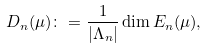Convert formula to latex. <formula><loc_0><loc_0><loc_500><loc_500>D _ { n } ( \mu ) \colon = \frac { 1 } { | \Lambda _ { n } | } \dim E _ { n } ( \mu ) ,</formula> 